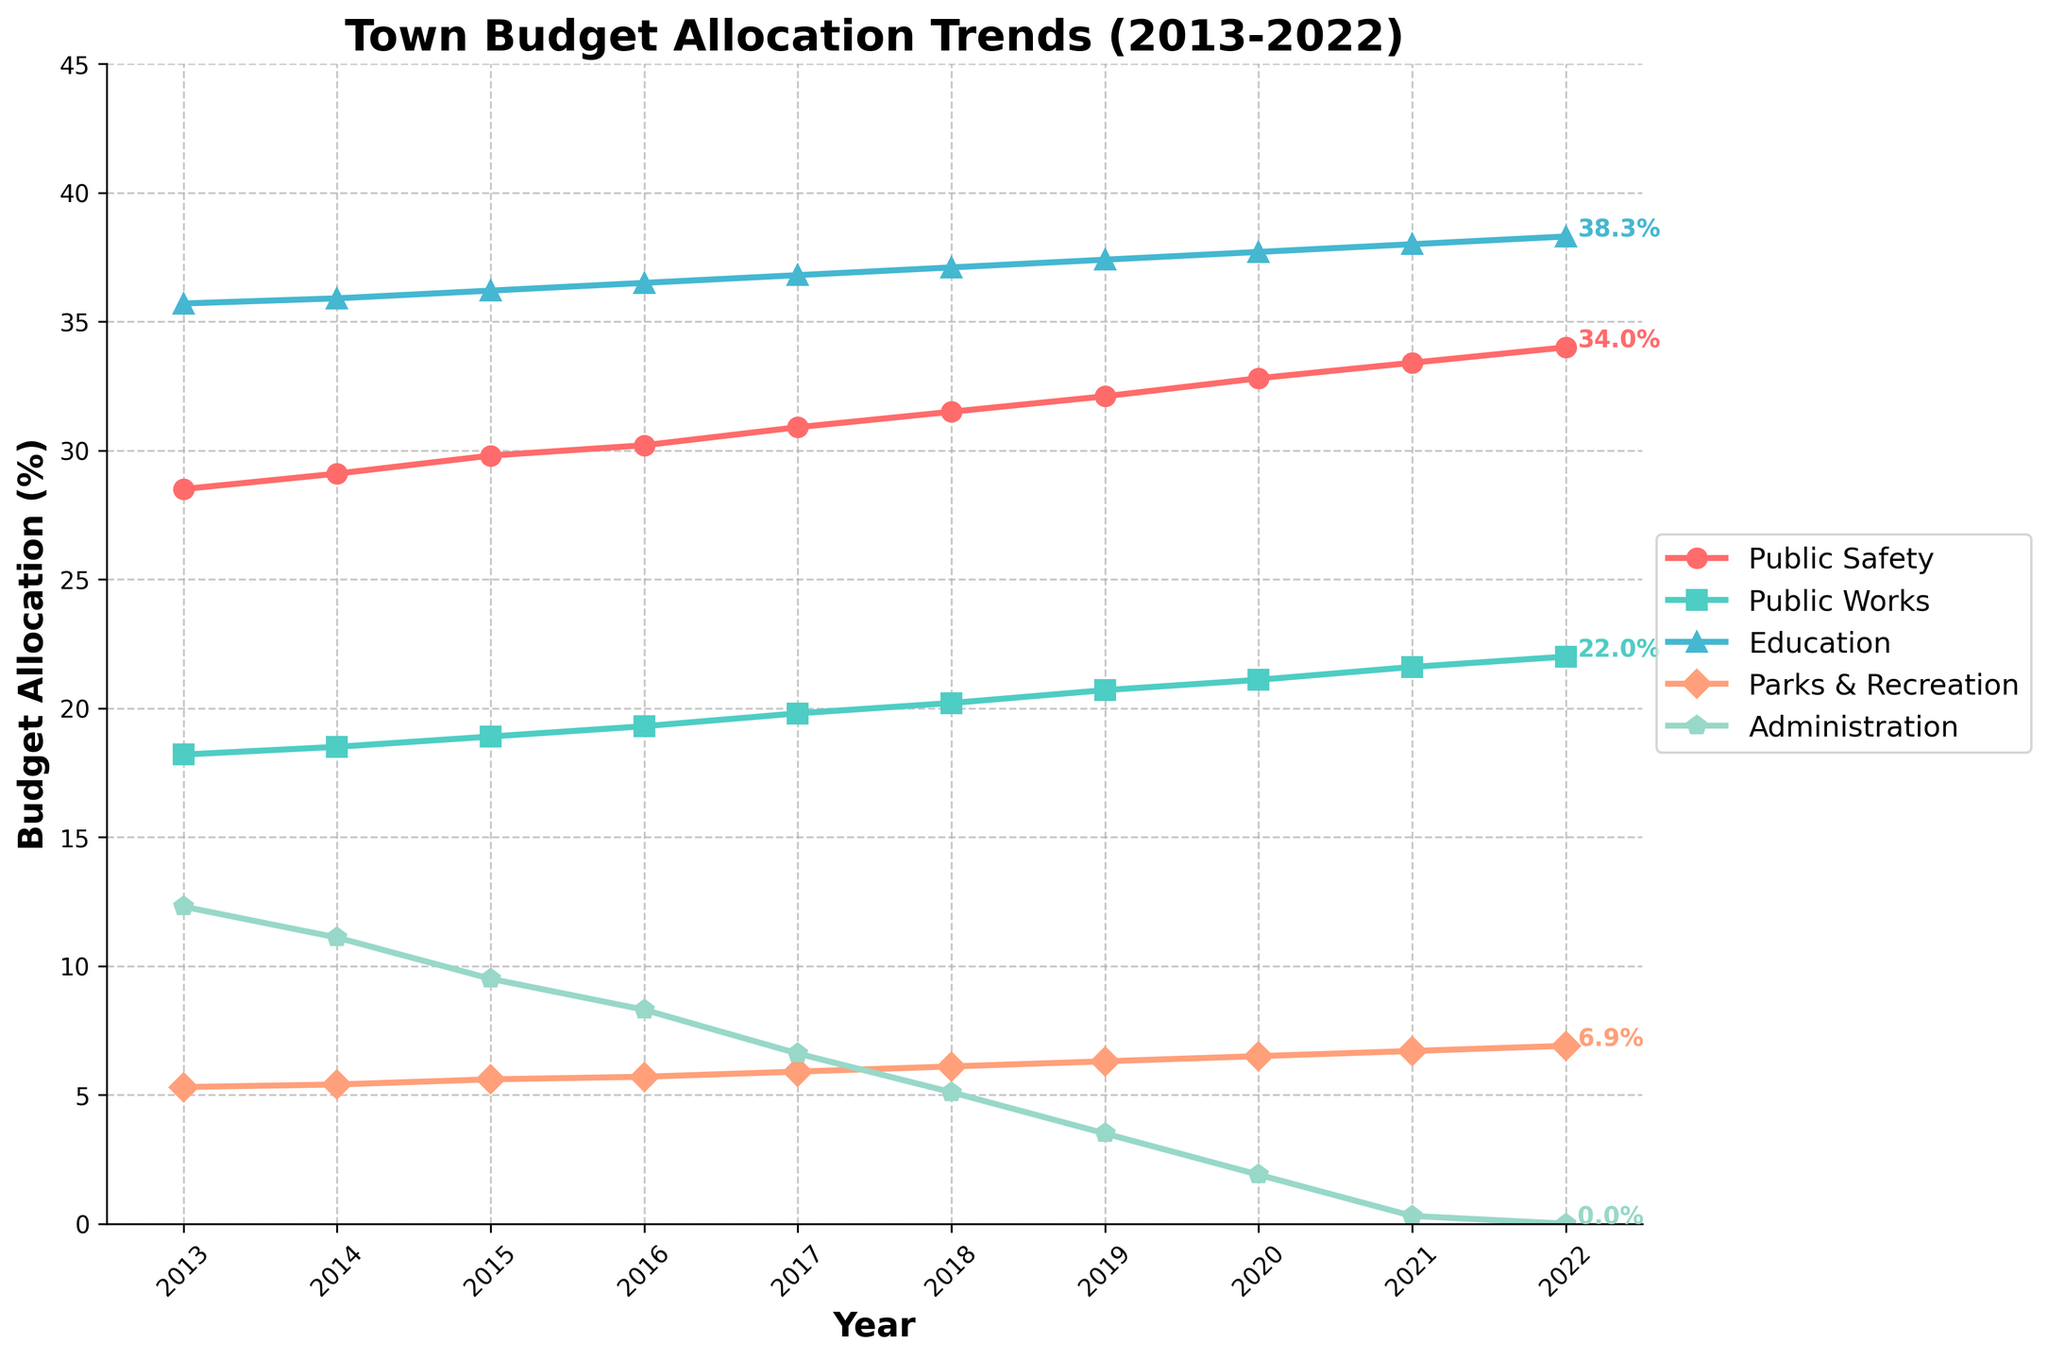How does the trend of budget allocation for Public Safety compare to Education from 2013 to 2022? Public Safety consistently increases from 28.5% to 34.0%, while Education rises more modestly from 35.7% to 38.3%.
Answer: Public Safety increases more steeply than Education Which department saw the smallest budget allocation by 2022, and what was the percentage? By 2022, Administration saw the smallest budget allocation with 0.0%.
Answer: Administration, 0.0% What is the combined budget allocation for Public Works and Parks & Recreation in 2015? Public Works is 18.9% and Parks & Recreation is 5.6% in 2015. Their sum is 18.9% + 5.6% = 24.5%.
Answer: 24.5% Which department had the greatest increase in budget allocation percentage from 2013 to 2022? Calculate the increases: Public Safety (34.0% - 28.5% = 5.5%), Public Works (22.0% - 18.2% = 3.8%), Education (38.3% - 35.7% = 2.6%), Parks & Recreation (6.9% - 5.3% = 1.6%), Administration (12.3% - 0.0% = -12.3%). Public Safety had the greatest increase.
Answer: Public Safety In which year did Education surpass 37%? Education surpassed 37% in 2018 when it reached 37.1%.
Answer: 2018 What is the average budget allocation for Public Works from 2013 to 2022? Sum the values from 2013 to 2022 for Public Works (18.2 + 18.5 + 18.9 + 19.3 + 19.8 + 20.2 + 20.7 + 21.1 + 21.6 + 22.0 = 200.3) and divide by the number of years (10): 200.3/10 = 20.03%.
Answer: 20.03% Which department had its budget allocation reduced to zero by 2022, and how was this trend over the decade? Administration was reduced to 0% by 2022. It consistently decreased from 12.3% in 2013, going through intermediate reductions each year until reaching 0%.
Answer: Administration, consistently decreased In 2020, which department had a larger budget allocation: Parks & Recreation or Administration, and by what margin? Parks & Recreation had 6.5% and Administration had 1.9% in 2020. The difference is 6.5% - 1.9% = 4.6%.
Answer: Parks & Recreation by 4.6% Compare the budget allocation trends between Public Works and Public Safety over the period. Which department shows more variability? Public Safety increased steadily from 28.5% to 34.0%. Public Works increased steadily but less steeply from 18.2% to 22.0%. Public Safety shows more variability because its allocation increase (5.5%) is larger compared to Public Works (3.8%).
Answer: Public Safety 